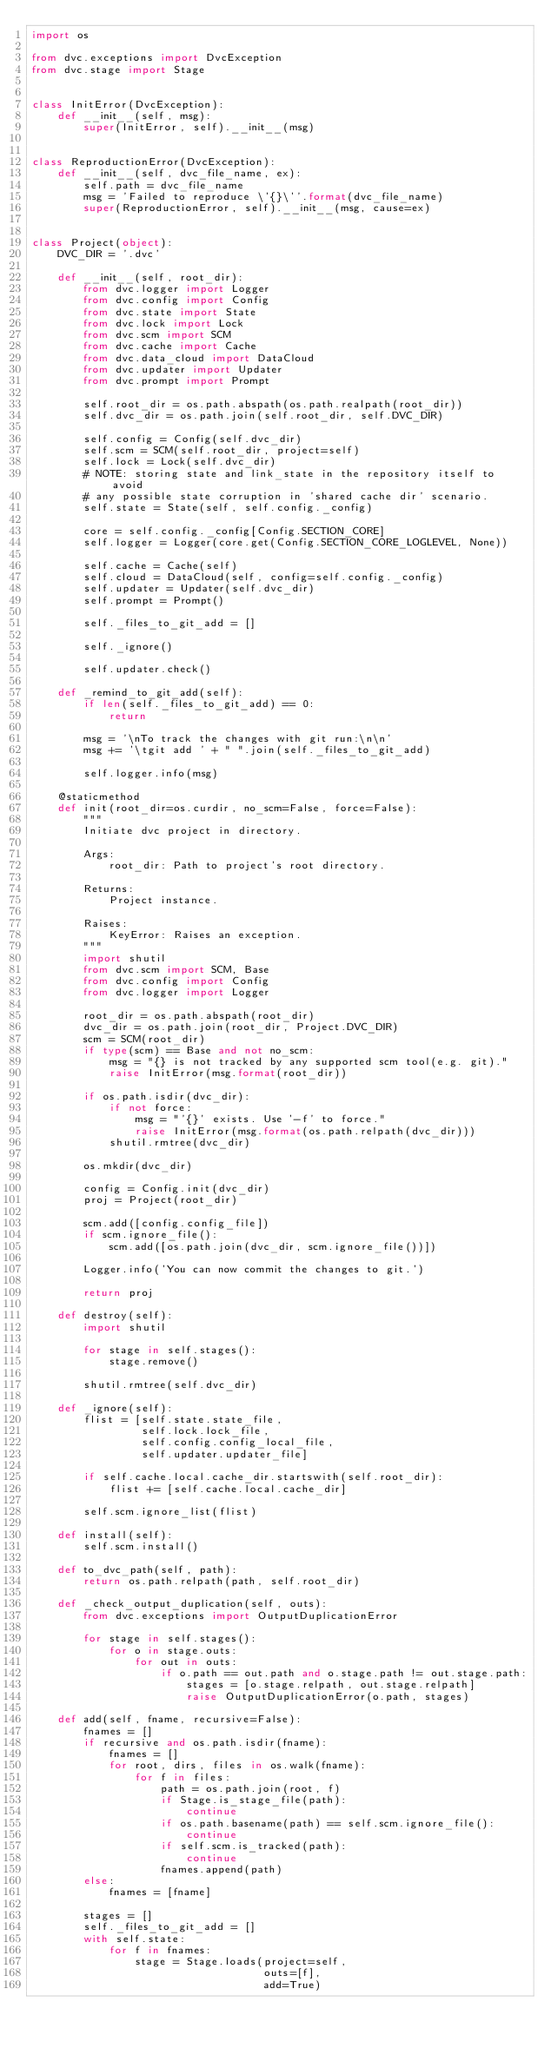Convert code to text. <code><loc_0><loc_0><loc_500><loc_500><_Python_>import os

from dvc.exceptions import DvcException
from dvc.stage import Stage


class InitError(DvcException):
    def __init__(self, msg):
        super(InitError, self).__init__(msg)


class ReproductionError(DvcException):
    def __init__(self, dvc_file_name, ex):
        self.path = dvc_file_name
        msg = 'Failed to reproduce \'{}\''.format(dvc_file_name)
        super(ReproductionError, self).__init__(msg, cause=ex)


class Project(object):
    DVC_DIR = '.dvc'

    def __init__(self, root_dir):
        from dvc.logger import Logger
        from dvc.config import Config
        from dvc.state import State
        from dvc.lock import Lock
        from dvc.scm import SCM
        from dvc.cache import Cache
        from dvc.data_cloud import DataCloud
        from dvc.updater import Updater
        from dvc.prompt import Prompt

        self.root_dir = os.path.abspath(os.path.realpath(root_dir))
        self.dvc_dir = os.path.join(self.root_dir, self.DVC_DIR)

        self.config = Config(self.dvc_dir)
        self.scm = SCM(self.root_dir, project=self)
        self.lock = Lock(self.dvc_dir)
        # NOTE: storing state and link_state in the repository itself to avoid
        # any possible state corruption in 'shared cache dir' scenario.
        self.state = State(self, self.config._config)

        core = self.config._config[Config.SECTION_CORE]
        self.logger = Logger(core.get(Config.SECTION_CORE_LOGLEVEL, None))

        self.cache = Cache(self)
        self.cloud = DataCloud(self, config=self.config._config)
        self.updater = Updater(self.dvc_dir)
        self.prompt = Prompt()

        self._files_to_git_add = []

        self._ignore()

        self.updater.check()

    def _remind_to_git_add(self):
        if len(self._files_to_git_add) == 0:
            return

        msg = '\nTo track the changes with git run:\n\n'
        msg += '\tgit add ' + " ".join(self._files_to_git_add)

        self.logger.info(msg)

    @staticmethod
    def init(root_dir=os.curdir, no_scm=False, force=False):
        """
        Initiate dvc project in directory.

        Args:
            root_dir: Path to project's root directory.

        Returns:
            Project instance.

        Raises:
            KeyError: Raises an exception.
        """
        import shutil
        from dvc.scm import SCM, Base
        from dvc.config import Config
        from dvc.logger import Logger

        root_dir = os.path.abspath(root_dir)
        dvc_dir = os.path.join(root_dir, Project.DVC_DIR)
        scm = SCM(root_dir)
        if type(scm) == Base and not no_scm:
            msg = "{} is not tracked by any supported scm tool(e.g. git)."
            raise InitError(msg.format(root_dir))

        if os.path.isdir(dvc_dir):
            if not force:
                msg = "'{}' exists. Use '-f' to force."
                raise InitError(msg.format(os.path.relpath(dvc_dir)))
            shutil.rmtree(dvc_dir)

        os.mkdir(dvc_dir)

        config = Config.init(dvc_dir)
        proj = Project(root_dir)

        scm.add([config.config_file])
        if scm.ignore_file():
            scm.add([os.path.join(dvc_dir, scm.ignore_file())])

        Logger.info('You can now commit the changes to git.')

        return proj

    def destroy(self):
        import shutil

        for stage in self.stages():
            stage.remove()

        shutil.rmtree(self.dvc_dir)

    def _ignore(self):
        flist = [self.state.state_file,
                 self.lock.lock_file,
                 self.config.config_local_file,
                 self.updater.updater_file]

        if self.cache.local.cache_dir.startswith(self.root_dir):
            flist += [self.cache.local.cache_dir]

        self.scm.ignore_list(flist)

    def install(self):
        self.scm.install()

    def to_dvc_path(self, path):
        return os.path.relpath(path, self.root_dir)

    def _check_output_duplication(self, outs):
        from dvc.exceptions import OutputDuplicationError

        for stage in self.stages():
            for o in stage.outs:
                for out in outs:
                    if o.path == out.path and o.stage.path != out.stage.path:
                        stages = [o.stage.relpath, out.stage.relpath]
                        raise OutputDuplicationError(o.path, stages)

    def add(self, fname, recursive=False):
        fnames = []
        if recursive and os.path.isdir(fname):
            fnames = []
            for root, dirs, files in os.walk(fname):
                for f in files:
                    path = os.path.join(root, f)
                    if Stage.is_stage_file(path):
                        continue
                    if os.path.basename(path) == self.scm.ignore_file():
                        continue
                    if self.scm.is_tracked(path):
                        continue
                    fnames.append(path)
        else:
            fnames = [fname]

        stages = []
        self._files_to_git_add = []
        with self.state:
            for f in fnames:
                stage = Stage.loads(project=self,
                                    outs=[f],
                                    add=True)
</code> 